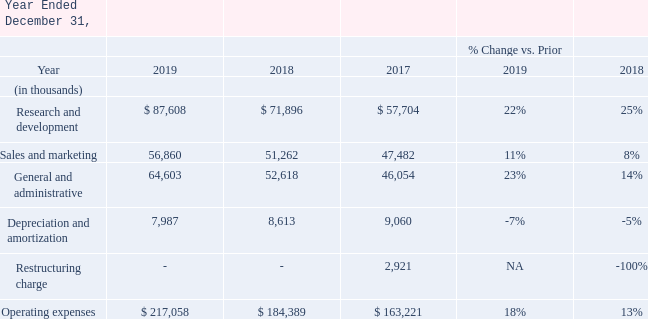Research and Development Our principal research and development (R&D) activities during 2019, 2018 and 2017 focused on the expansion and integration of new products and releases, while expanding the product footprint of our software solution suites in Supply Chain, Inventory Optimization and Omnichannel including cloud-based solutions, point-of-sale and tablet retailing. For 2019, 2018 and 2017, we did not capitalize any R&D costs because the costs incurred following the attainment of technological feasibility for the related software product through the date of general release were insignificant. Our principal research and development (R&D) activities during 2019, 2018 and 2017 focused on the expansion and integration of new products and releases, while expanding the product footprint of our software solution suites in Supply Chain, Inventory Optimization and Omnichannel including cloud-based solutions, point-of-sale and tablet retailing. For 2019, 2018 and 2017, we did not capitalize any R&D costs because the costs incurred following the attainment of technological feasibility for the related software product through the date of general release were insignificant. Our principal research and development (R&D) activities during 2019, 2018 and 2017 focused on the expansion and integration of new products and releases, while expanding the product footprint of our software solution suites in Supply Chain, Inventory Optimization and Omnichannel including cloud-based solutions, point-of-sale and tablet retailing. For 2019, 2018 and 2017, we did not capitalize any R&D costs because the costs incurred following the attainment of technological feasibility for the related software product through the date of general release were insignificant.
Our principal research and development (R&D) activities during 2019, 2018 and 2017 focused on the expansion and integration of new products and releases, while expanding the product footprint of our software solution suites in Supply Chain, Inventory Optimization and Omnichannel including cloud-based solutions, point-of-sale and tablet retailing.
For 2019, 2018 and 2017, we did not capitalize any R&D costs because the costs incurred following the attainment of technological
feasibility for the related software product through the date of general release were insignificant.
Year 2019 compared with year 2018 R&D expenses primarily consist of salaries and other personnel-related costs for personnel involved in our research and development activities. Research and development expenses in 2019 increased by $15.7 million, or 22%, compared to 2018. This increase is primarily due to a $10.6 million increase in compensation and other personnel-related expenses, $3.0 million increase in performance-based compensation expense, and $1.7 million increase in computer infrastructure costs, resulting from increased headcount to support R&D activities.
Year 2018 compared with year 2017
Research and development expenses in 2018 increased by $14.2 million compared to 2017. The increase is primarily attributable to
an $8.9 million increase in compensation and other personnel-related expenses, resulting from increased headcount to support R&D
activities, a $4.0 million increase in performance-based compensation and a $0.7 million increase in computer infrastructure costs.
Sales and Marketing Year 2019 compared with year 2018 Sales and marketing expenses include salaries, commissions, travel and other personnel-related costs and the costs of our marketing and alliance programs and related activities. Sales and marketing expenses increased by $5.6 million, or 11%, in 2019 compared to 2018, primarily due to a $4.9 million increase in performance-based compensation expense and a $2.5 million increase in compensation and other personnel-related expenses, offset by a $1.9 million decrease in marketing related expenses. Year 2019 compared with year 2018 Sales and marketing expenses include salaries, commissions, travel and other personnel-related costs and the costs of our marketing and alliance programs and related activities. Sales and marketing expenses increased by $5.6 million, or 11%, in 2019 compared to 2018, primarily due to a $4.9 million increase in performance-based compensation expense and a $2.5 million increase in compensation and other personnel-related expenses, offset by a $1.9 million decrease in marketing related expenses.
Year 2018 compared with year 2017 Sales and marketing expenses increased $3.8 million in 2018 compared to 2017, due primarily to an increase of $2.9 million in marketing and campaign programs, a $1.1 million increase in performance-based compensation and a $0.7 million increase in compensation and other personnel-related expenses, partially offset by a $2.0 million decrease in commissions expense as we must defer a portion of our sales commission expense and amortize it over time as the corresponding services are transferred to the customer under ASC 606. Sales and marketing expenses increased $3.8 million in 2018 compared to 2017, due primarily to an increase of $2.9 million in marketing and campaign programs, a $1.1 million increase in performance-based compensation and a $0.7 million increase in compensation and other personnel-related expenses, partially offset by a $2.0 million decrease in commissions expense as we must defer a portion of our sales commission expense and amortize it over time as the corresponding services are transferred to the customer under ASC 606. Sales and marketing expenses increased $3.8 million in 2018 compared to 2017, due primarily to an increase of $2.9 million in marketing and campaign programs, a $1.1 million increase in performance-based compensation and a $0.7 million increase in compensation and other personnel-related expenses, partially offset by a $2.0 million decrease in commissions expense as we must defer a portion of our sales commission expense and amortize it over time as the corresponding services are transferred to the customer under ASC 606.
Sales and marketing expenses increased $3.8 million in 2018 compared to 2017, due primarily to an increase of $2.9 million in marketing and campaign programs, a $1.1 million increase in performance-based compensation and a $0.7 million increase in compensation and other personnel-related expenses, partially offset by a $2.0 million decrease in commissions expense as we must defer a portion of our sales commission expense and amortize it over time as the corresponding services are transferred to the customer under ASC 606.
General and Administrative Year 2019 compared with year 2018 General and administrative expenses consist primarily of salaries and other personnel-related costs of executive, financial, human resources, information technology, and administrative personnel, as well as facilities, legal, insurance, accounting, and other
Year 2019 compared with year 2018
General and administrative expenses consist primarily of salaries and other personnel-related costs of executive, financial, human resources, information technology, and administrative personnel, as well as facilities, legal, insurance, accounting, and other administrative expenses. General and administrative expenses increased $12.0 million, or 23%, in 2019 primarily attributable to a $8.9
million increase in compensation and other personnel-related expenses resulting from increased headcount, a $1.9 million increase in performance-based compensation expense, and a $1.1 million increase in computer infrastructure costs.
Year 2018 compared with year 2017 General and administrative expenses increased $6.6 million in 2018 due primarily to a $3.6 million increase in compensation and other personnel-related expenses and a $2.4 million increase in performance-based compensation.
Depreciation and Amortization Depreciation and amortization of intangibles and software expense amounted to $8.0 million, $8.6 million, and $9.1 million in 2019, 2018 and 2017, respectively. Amortization of intangibles was immaterial in 2019, 2018 and 2017. We have recorded goodwill and other acquisition-related intangible assets as part of the purchase accounting associated with various acquisitions.
Depreciation and amortization of intangibles and software expense amounted to $8.0 million, $8.6 million, and $9.1 million in 2019, 2018 and 2017, respectively. Amortization of intangibles was immaterial in 2019, 2018 and 2017. We have recorded goodwill and other acquisition-related intangible assets as part of the purchase accounting associated with various acquisitions.
Restructuring Charge In May 2017, we eliminated about 100 positions due primarily to U.S. retail sector headwinds, aligning services capacity with demand. We recorded a restructuring charge of approximately $2.9 million pretax ($1.8 million after-tax or $0.03 per fully diluted share). The charge primarily consisted of employee severance, employee transition costs and outplacement services. The charge is classified in “Restructuring charge” in our Consolidated Statements of Income.
In May 2017, we eliminated about 100 positions due primarily to U.S. retail sector headwinds, aligning services capacity with demand. We recorded a restructuring charge of approximately $2.9 million pretax ($1.8 million after-tax or $0.03 per fully diluted share). The charge primarily consisted of employee severance, employee transition costs and outplacement services. The charge is classified in “Restructuring charge” in our Consolidated Statements of Income.
Operating Income
Operating income in 2019 decreased $18.0 million to $115.9 million, compared to $133.9 million for 2018. Operating margins
were 18.8% for 2019 versus 23.9% for 2018. Operating income and margin decreased primarily due to our commitment to
strategically invest in a business transition to a cloud first company focused on delivering long-term sustainable growth and earnings
leverage. As a result, we are investing significantly in R&D to deliver new innovation, cloud operations headcount, infrastructure and
technology to support our ability to scale our cloud business to achieve our growth objectives. In addition, our innovation releases have fueled strong demand for our global consulting services and we are actively hiring to fulfill customer demand, which pressures operating income and margins until new resources ramp to full utilization. Finally, our performance-based compensation expense has increased over the prior year based on strong execution against target objectives. In 2019, operating income in the Americas segment decreased by $18.9 million and remained relatively flat in the EMEA and APAC segments.
Operating income in 2018 decreased $51.7 million to $133.9 million, compared to $185.6 million for 2017. Operating margins were 23.9% for 2018 versus 31.2% for 2017. Operating income and margin decreased primarily as a result of our investment in cloud transition combined with lower license revenue. The operating income decrease in the Americas, EMEA and APAC segments was
$39.1 million, $9.4 million and $3.2 million, respectively.
What is the change in research and development cost between 2019 and 2018?
Answer scale should be: thousand. $87,608-$71,896
Answer: 15712. Which year has a higher Sales and Marketing expense? 56,860> 51,262>47,482
Answer: 2019. What is the change in depreciation and amortization cost between 2019 and 2018?
Answer scale should be: thousand. $8,613-7,987
Answer: 626. How many positions are eliminated in 2017 May? About 100. What is the research and development expense in 2019?
Answer scale should be: thousand. $ 87,608. What is the sales and marketing expense increase in 2018 from 2017? $3.8 million. 